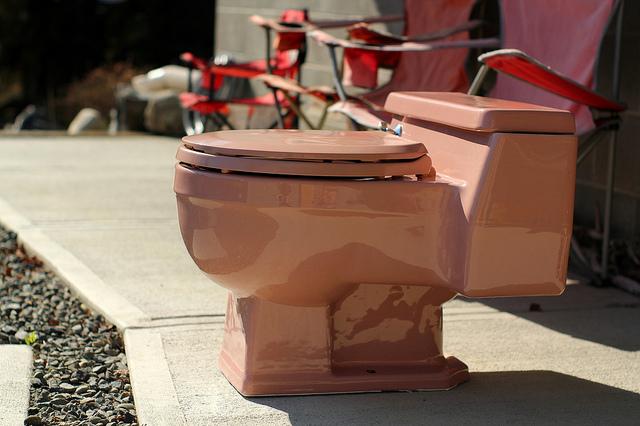Are these toilets for sale?
Be succinct. No. Where are the red chairs?
Be succinct. Behind toilet. Is it night time?
Answer briefly. No. What is the purpose of this structure?
Keep it brief. Toilet. What color is toilet 11?
Concise answer only. Pink. Does the toilet work?
Concise answer only. No. What color is the toilet?
Write a very short answer. Brown. 